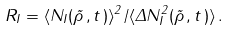Convert formula to latex. <formula><loc_0><loc_0><loc_500><loc_500>R _ { I } = \langle N _ { I } ( { \vec { \rho } } \, , t \, ) \rangle ^ { 2 } / \langle \Delta N _ { I } ^ { 2 } ( { \vec { \rho } } \, , t \, ) \rangle \, .</formula> 